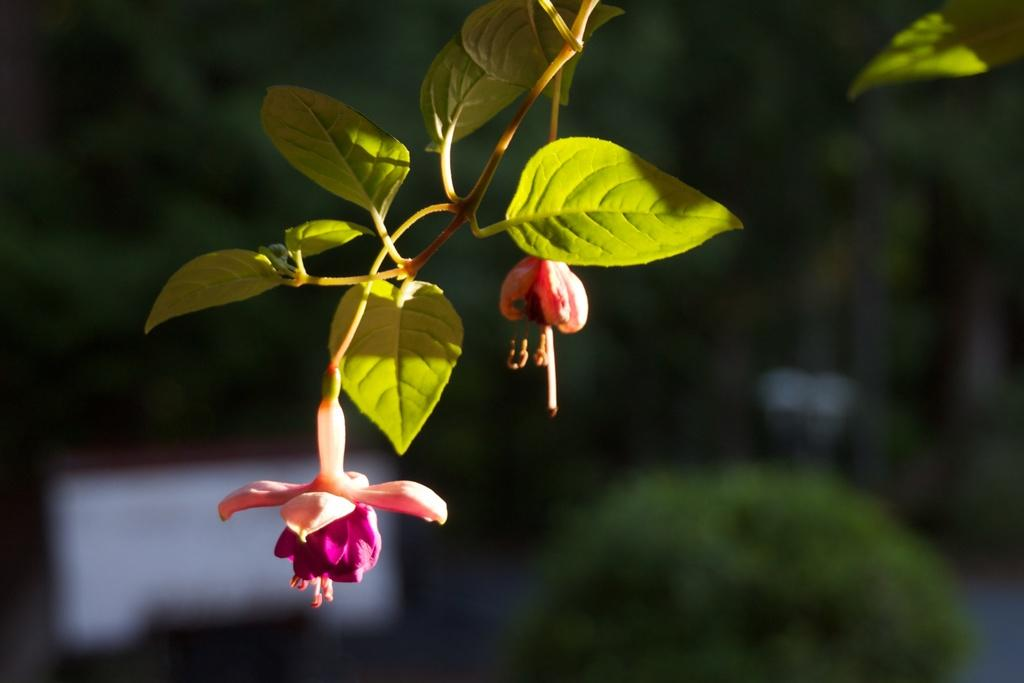What type of living organisms can be seen in the image? There are flowers on a plant in the image. Can you describe the background of the image? The background of the image is blurry. What type of tooth can be seen in the image? There is no tooth present in the image; it features flowers on a plant. What mode of transportation is depicted in the image? There is no mode of transportation depicted in the image. 